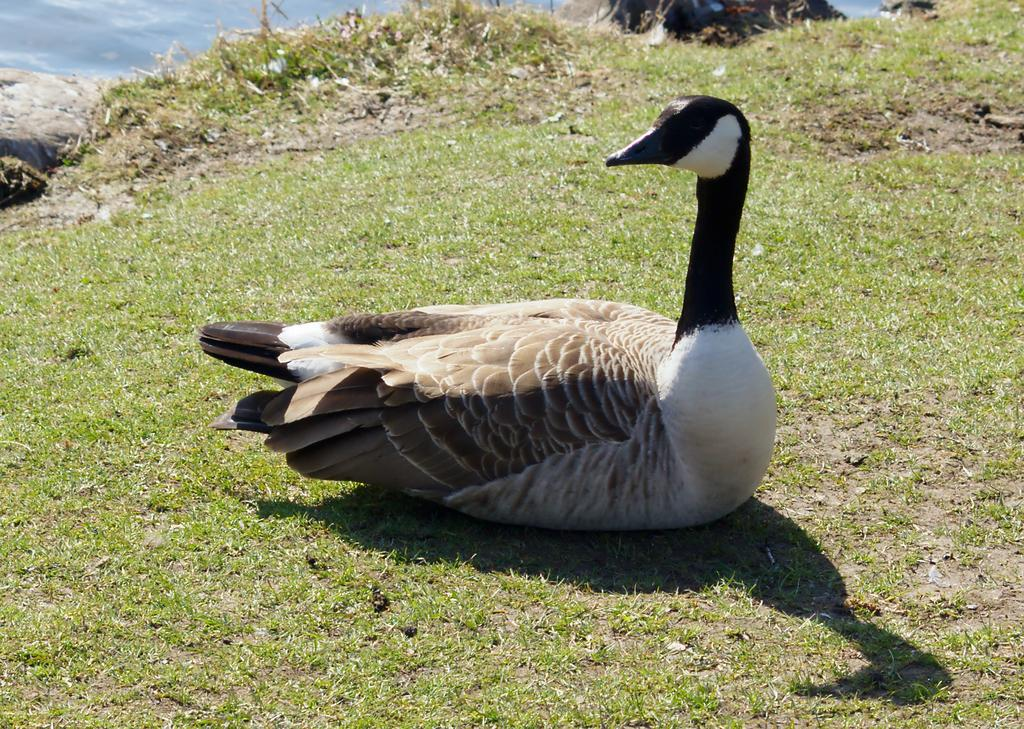What is the main subject in the center of the image? There is a duck in the center of the image. Where is the duck located? The duck is on the grass. What can be seen in the background of the image? There is water and grass visible in the background of the image. What type of gun is being used to gain approval from the duck in the image? There is no gun or approval-seeking behavior present in the image; it features a duck on the grass with water and grass visible in the background. 